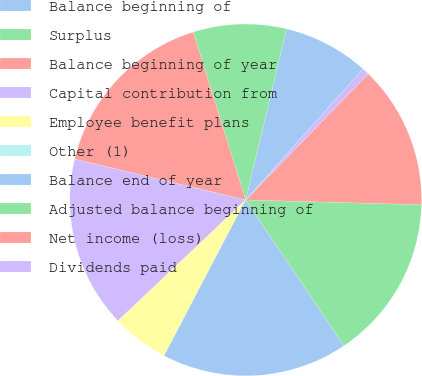Convert chart to OTSL. <chart><loc_0><loc_0><loc_500><loc_500><pie_chart><fcel>Balance beginning of<fcel>Surplus<fcel>Balance beginning of year<fcel>Capital contribution from<fcel>Employee benefit plans<fcel>Other (1)<fcel>Balance end of year<fcel>Adjusted balance beginning of<fcel>Net income (loss)<fcel>Dividends paid<nl><fcel>7.89%<fcel>8.55%<fcel>16.45%<fcel>15.79%<fcel>5.26%<fcel>0.0%<fcel>17.11%<fcel>15.13%<fcel>13.16%<fcel>0.66%<nl></chart> 